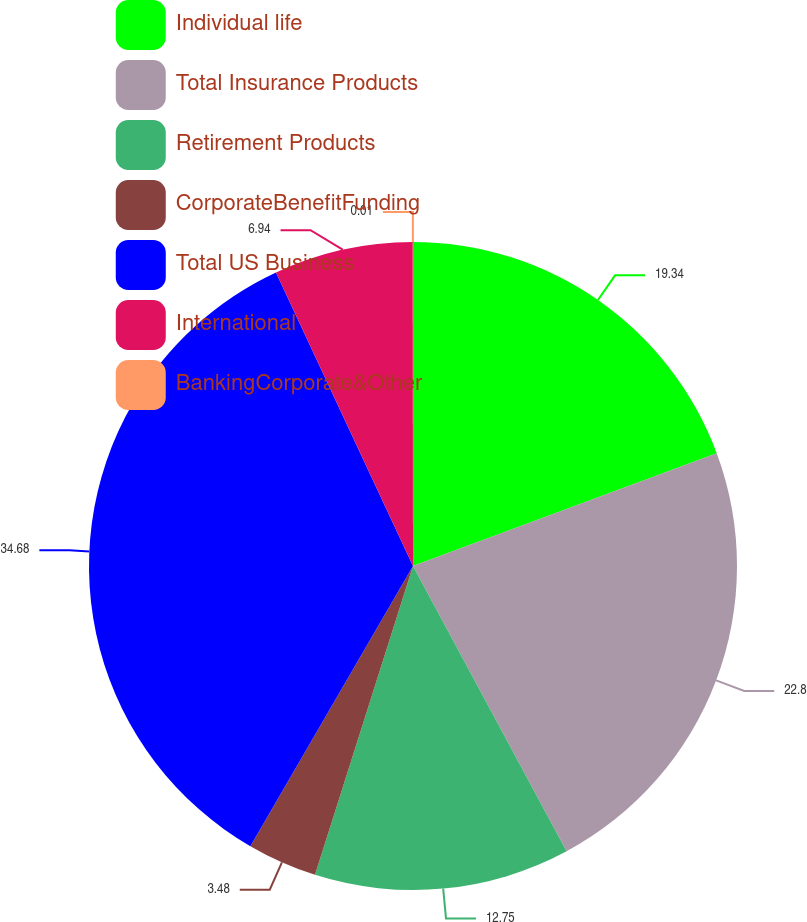Convert chart to OTSL. <chart><loc_0><loc_0><loc_500><loc_500><pie_chart><fcel>Individual life<fcel>Total Insurance Products<fcel>Retirement Products<fcel>CorporateBenefitFunding<fcel>Total US Business<fcel>International<fcel>BankingCorporate&Other<nl><fcel>19.34%<fcel>22.8%<fcel>12.75%<fcel>3.48%<fcel>34.68%<fcel>6.94%<fcel>0.01%<nl></chart> 